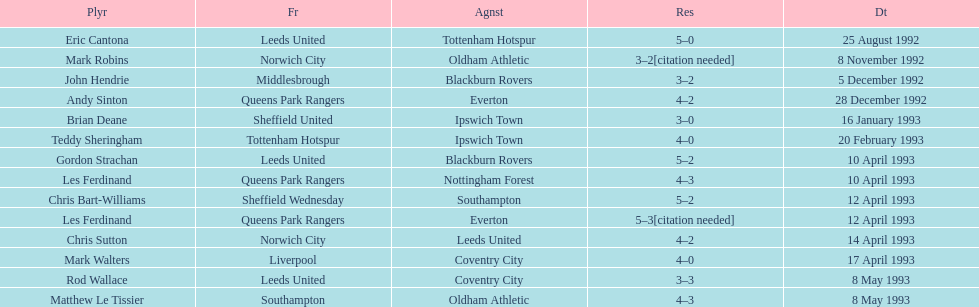Which team did liverpool play against? Coventry City. 